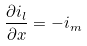Convert formula to latex. <formula><loc_0><loc_0><loc_500><loc_500>\frac { \partial i _ { l } } { \partial x } = - i _ { m }</formula> 